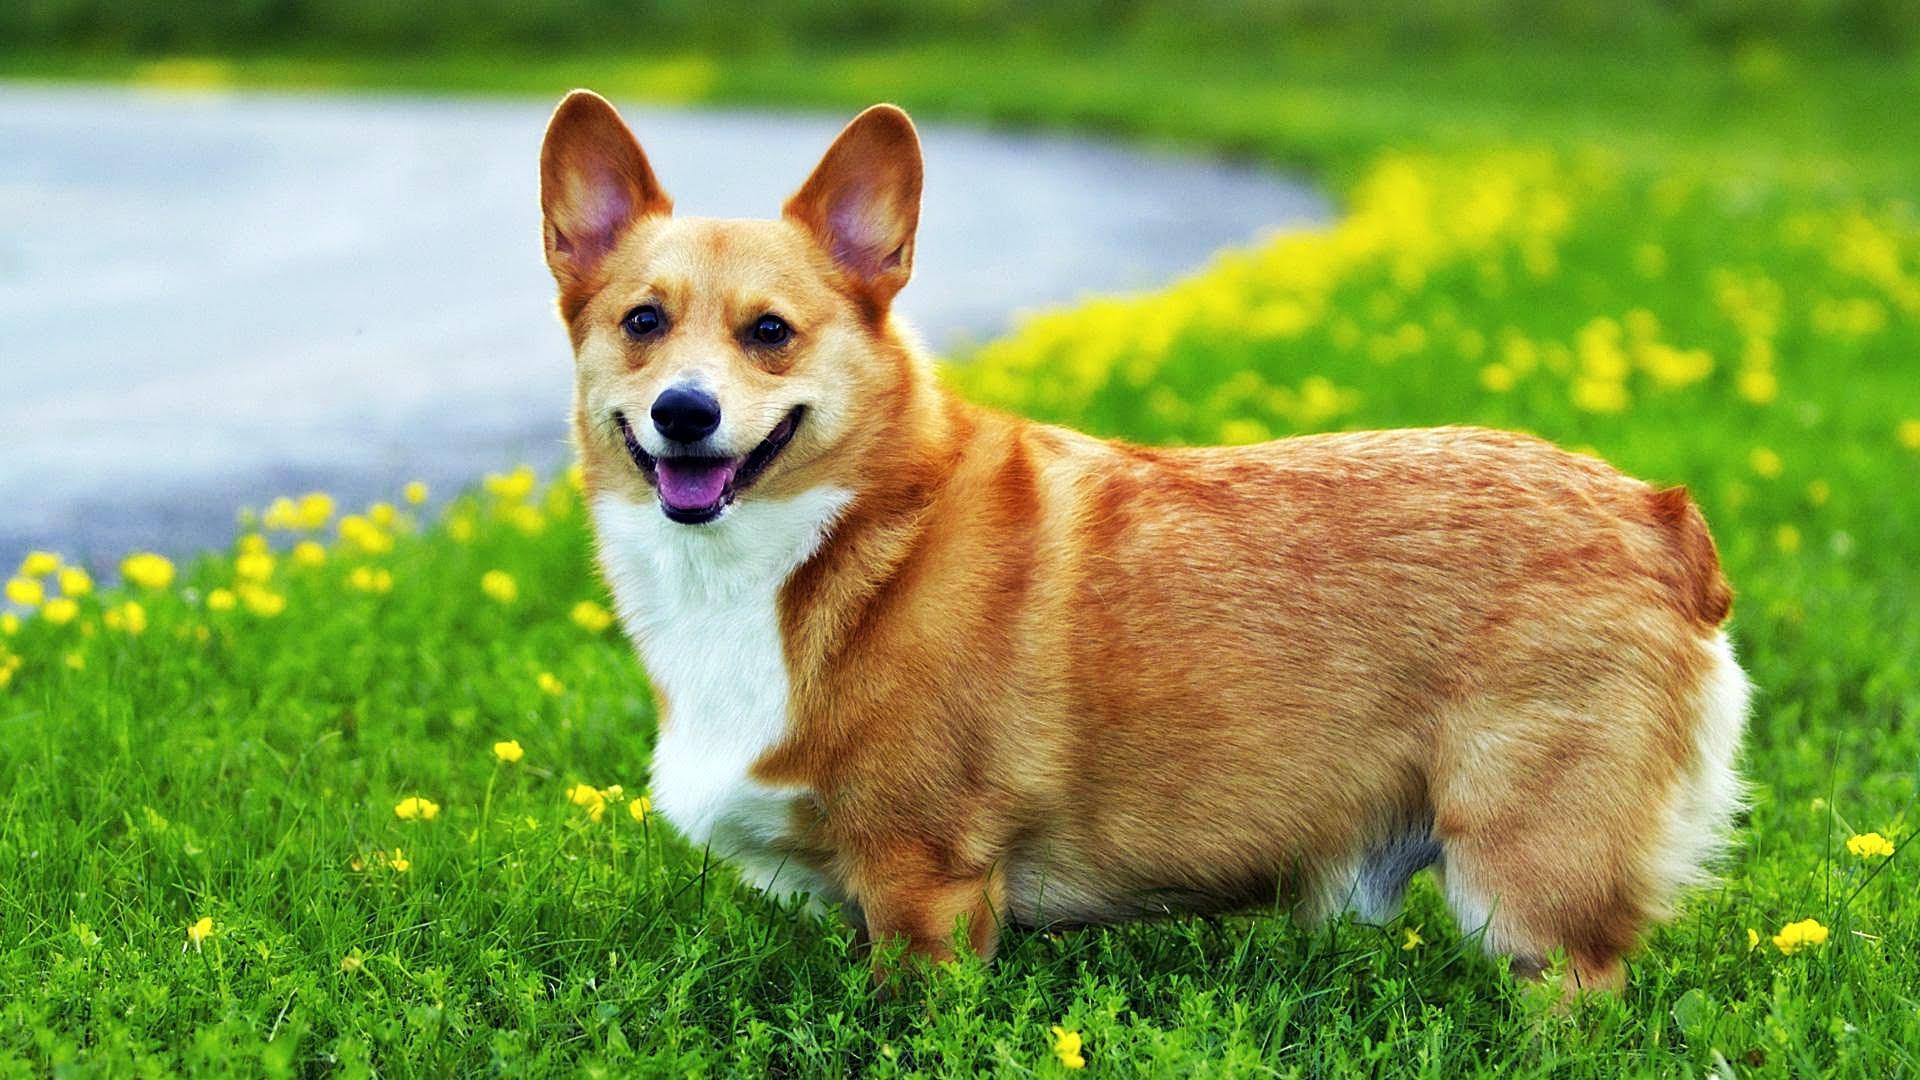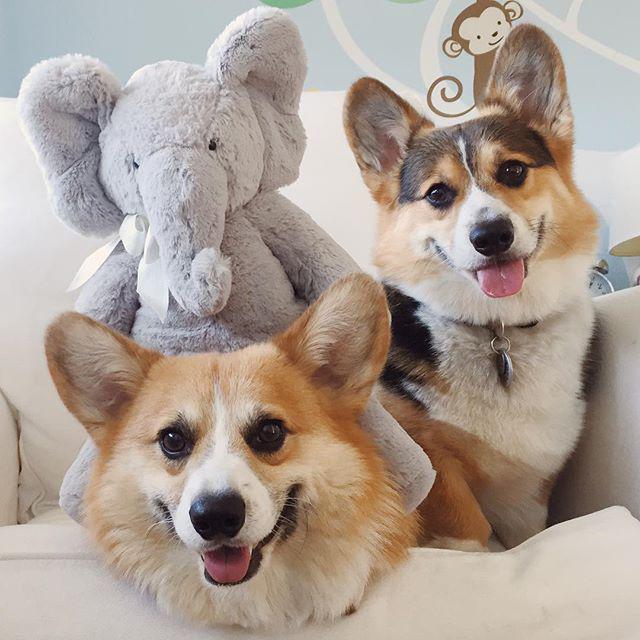The first image is the image on the left, the second image is the image on the right. Assess this claim about the two images: "One image shows a corgi standing with its body turned leftward and its smiling face turned to the camera.". Correct or not? Answer yes or no. Yes. The first image is the image on the left, the second image is the image on the right. Given the left and right images, does the statement "There are exactly 3 dogs, and they are all outside." hold true? Answer yes or no. No. 